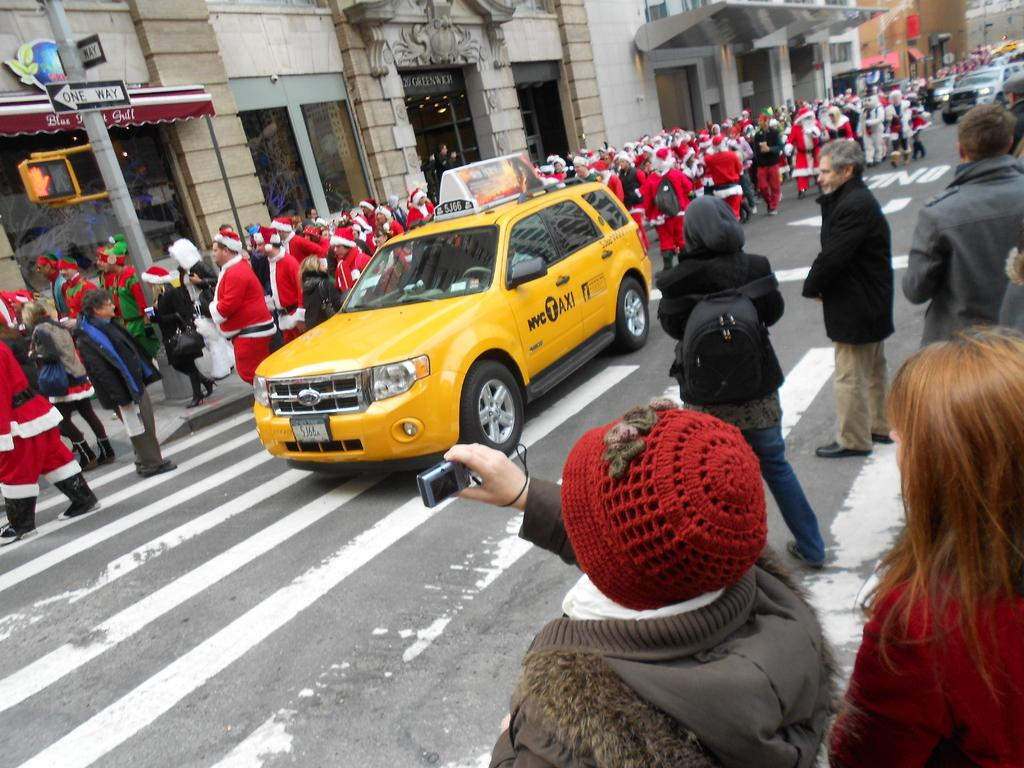<image>
Offer a succinct explanation of the picture presented. A group of Santas walk down a one way street next to a NYC Taxi. 